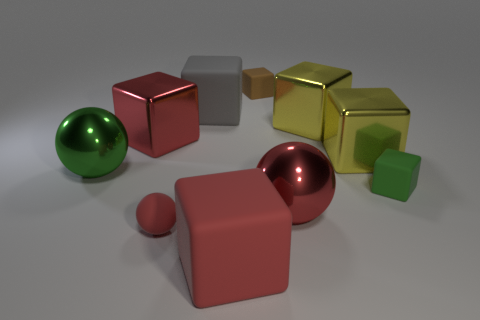Subtract all large rubber cubes. How many cubes are left? 5 Subtract all yellow blocks. How many blocks are left? 5 Subtract 1 cubes. How many cubes are left? 6 Subtract all purple blocks. Subtract all green cylinders. How many blocks are left? 7 Subtract all balls. How many objects are left? 7 Add 1 big green things. How many big green things are left? 2 Add 7 green matte cubes. How many green matte cubes exist? 8 Subtract 1 gray blocks. How many objects are left? 9 Subtract all yellow metallic things. Subtract all large red matte blocks. How many objects are left? 7 